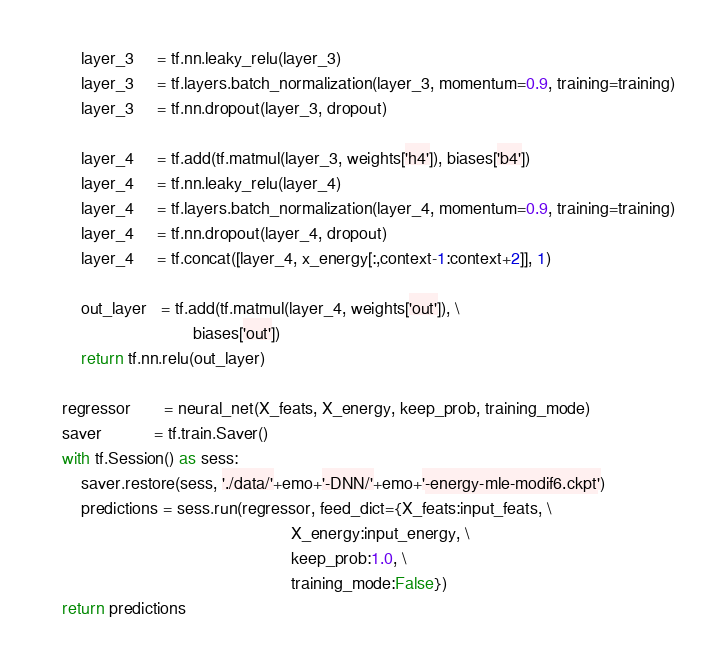<code> <loc_0><loc_0><loc_500><loc_500><_Python_>        layer_3     = tf.nn.leaky_relu(layer_3)
        layer_3     = tf.layers.batch_normalization(layer_3, momentum=0.9, training=training)
        layer_3     = tf.nn.dropout(layer_3, dropout)
        
        layer_4     = tf.add(tf.matmul(layer_3, weights['h4']), biases['b4'])
        layer_4     = tf.nn.leaky_relu(layer_4)
        layer_4     = tf.layers.batch_normalization(layer_4, momentum=0.9, training=training)
        layer_4     = tf.nn.dropout(layer_4, dropout)
        layer_4     = tf.concat([layer_4, x_energy[:,context-1:context+2]], 1)
    
        out_layer   = tf.add(tf.matmul(layer_4, weights['out']), \
                                biases['out'])
        return tf.nn.relu(out_layer)
    
    regressor       = neural_net(X_feats, X_energy, keep_prob, training_mode)
    saver           = tf.train.Saver()
    with tf.Session() as sess:
        saver.restore(sess, './data/'+emo+'-DNN/'+emo+'-energy-mle-modif6.ckpt')
        predictions = sess.run(regressor, feed_dict={X_feats:input_feats, \
                                                     X_energy:input_energy, \
                                                     keep_prob:1.0, \
                                                     training_mode:False})
    return predictions
</code> 